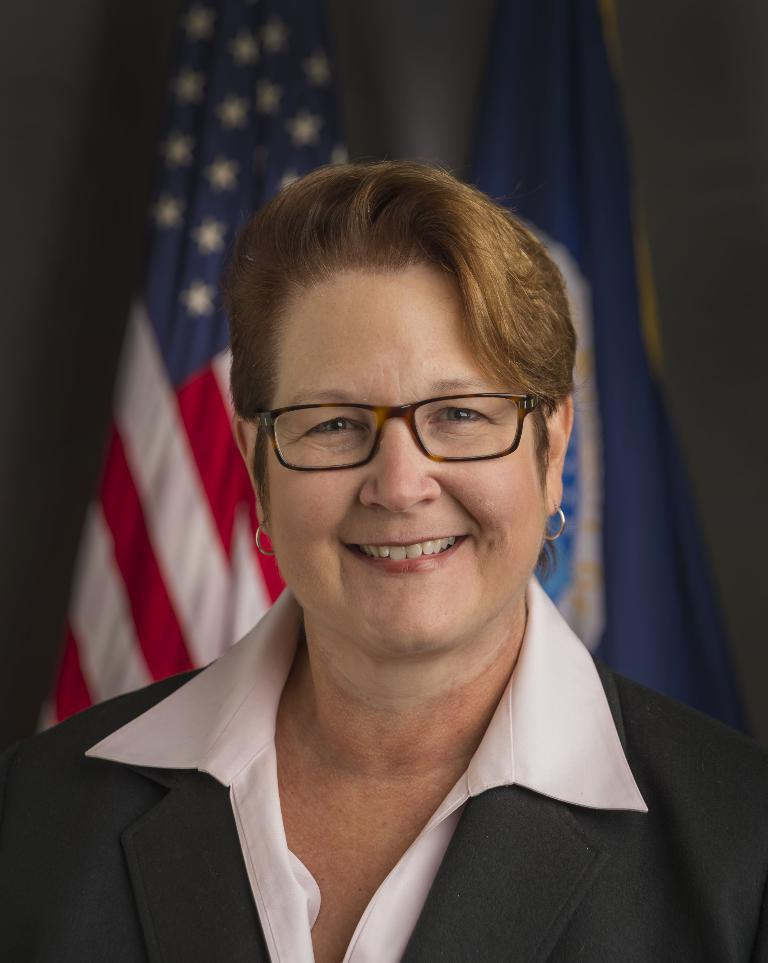Who is present in the image? There is a woman in the image. What is the woman wearing? The woman is wearing glasses. What is the woman's facial expression? The woman is smiling. What can be seen in the background of the image? There are flags in the background of the image. What type of hose is being used by the woman in the image? There is no hose present in the image; the woman is simply wearing glasses and smiling. 